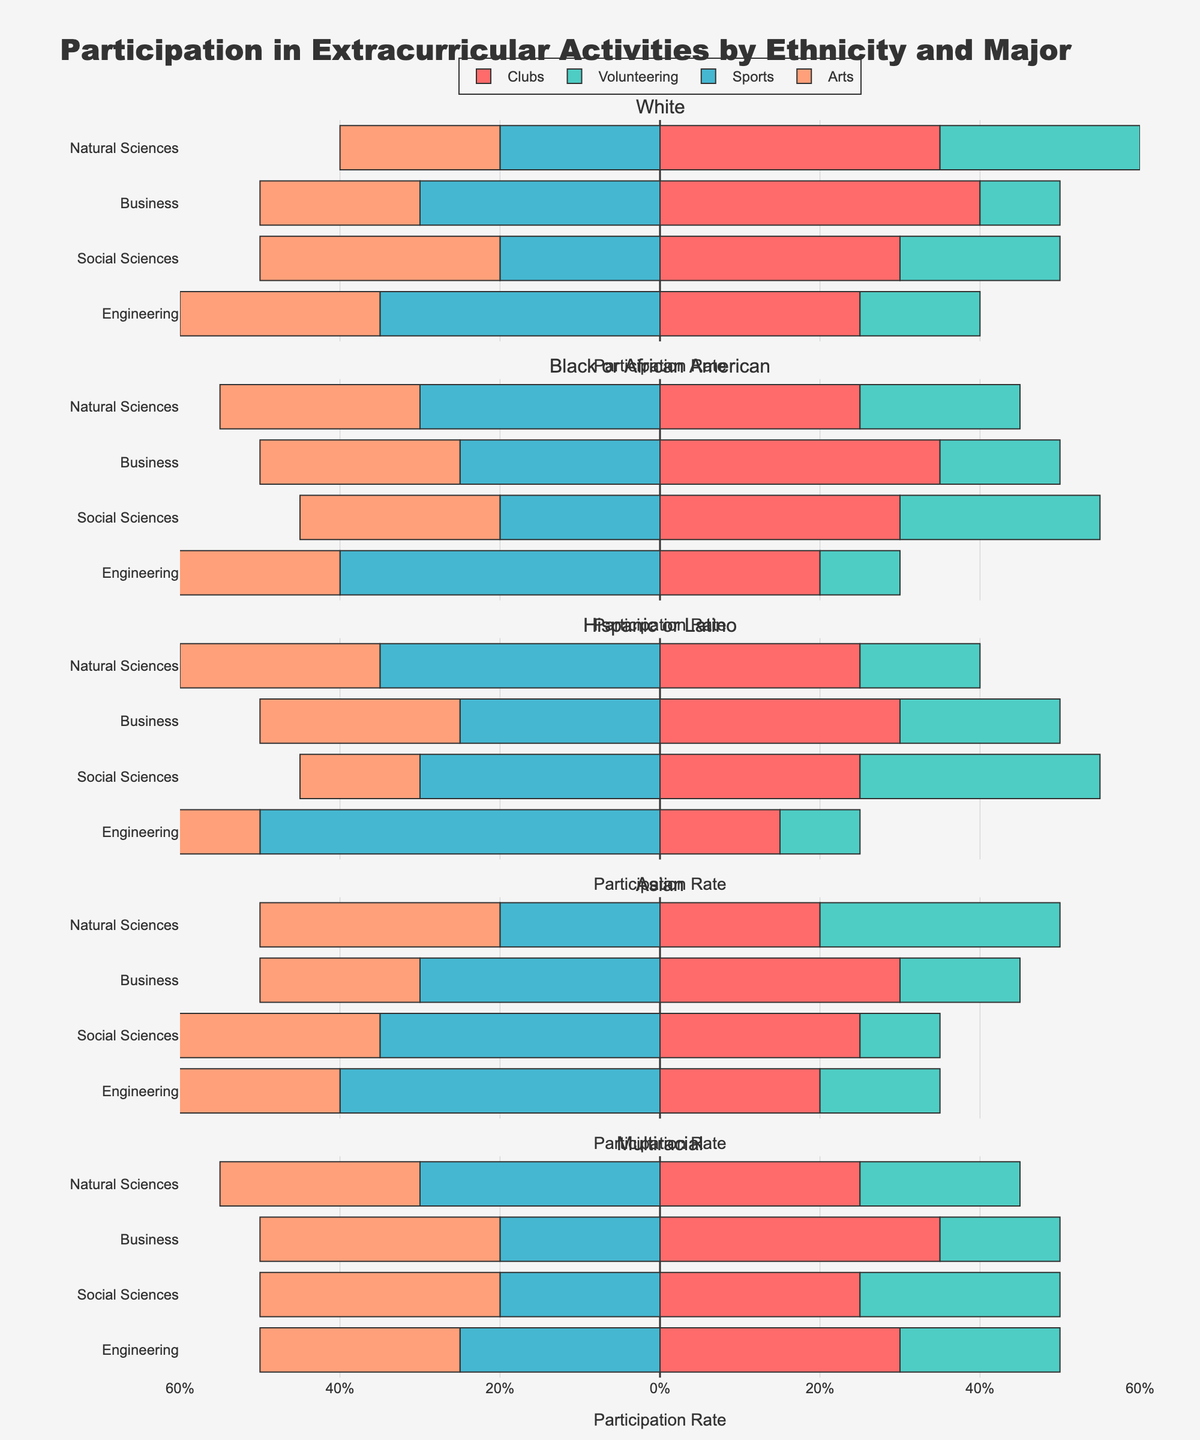Which extracurricular activity has the highest participation rate among White students in the Engineering major? The chart associated with White students in the Engineering major needs to be examined. The longest bar indicates the highest participation rate. In this case, the longest bar is the one representing Sports.
Answer: Sports In which major do Black or African American students have the highest rate of participation in Volunteering? Examine the section for Black or African American students and compare the lengths of the green bars (Volunteering) across different majors. The longest green bar is seen in the Social Sciences major.
Answer: Social Sciences Among Hispanic or Latino students, which activity has the least participation rate in the Social Sciences major? Look at the section for Hispanic or Latino students in the Social Sciences major and identify the shortest bar. The shortest bar represents Arts.
Answer: Arts Comparing participation in Sports among Engineering majors, which ethnicity has the highest rate? Check the red bars (Sports) within the Engineering majors for all ethnicities. The longest red bar is found among Hispanic or Latino students.
Answer: Hispanic or Latino Which ethnicity shows the most balanced participation across all four activities within the Natural Sciences major? Balanced participation implies bars of relatively equal length for each activity. By examining the section for Natural Sciences majors across ethnicities, Multiracial students show the most balanced participation with similar bar lengths.
Answer: Multiracial How does Black or African American student participation in Arts for the Business major compare to Asian student participation in Arts for the same major? Compare the length of the yellow bars (Arts) for Black or African American and Asian students in the Business major. Both ethnicities have bars of the same length for Arts.
Answer: Equal What is the approximate difference in participation rates in Clubs between White and Multiracial students in the Business major? In the Business major, compare the lengths of the dark blue bars (Clubs) for White and Multiracial students. The difference in length, corresponding to their participation rates, is about 5%.
Answer: 5% Which major has the highest participation rate in Clubs among Asian students, and what is the rate? Check the section for Asian students and identify the longest dark blue bar (Clubs) among majors. The highest participation rate is in the Business major with a rate of 30%.
Answer: Business, 30% What is the total participation rate in Volunteering for Hispanic or Latino students across all majors? Examine the green bars (Volunteering) for Hispanic or Latino students across all majors and sum their lengths: 10% (Engineering) + 30% (Social Sciences) + 20% (Business) + 15% (Natural Sciences). The total participation is 75%.
Answer: 75% Which ethnicity and major combination has the lowest participation rate in Sports, and what is the rate? Review the red bars (Sports) in each ethnicity-major combination to find the shortest bar. White students in the Social Sciences major have the shortest bar in Sports, indicating a rate of 20%.
Answer: White, Social Sciences, 20% 